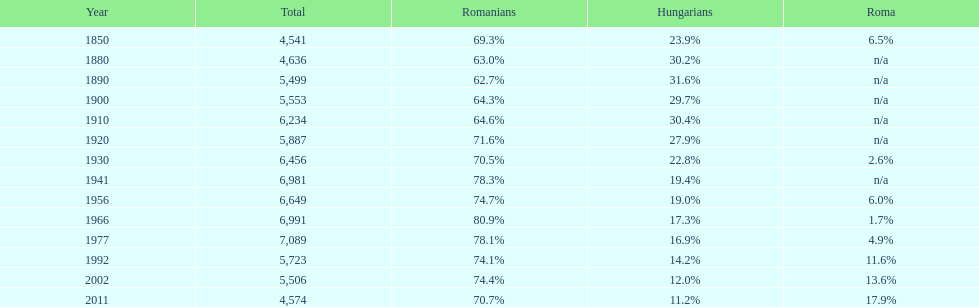What is the number of times the total population was 6,000 or more? 6. 